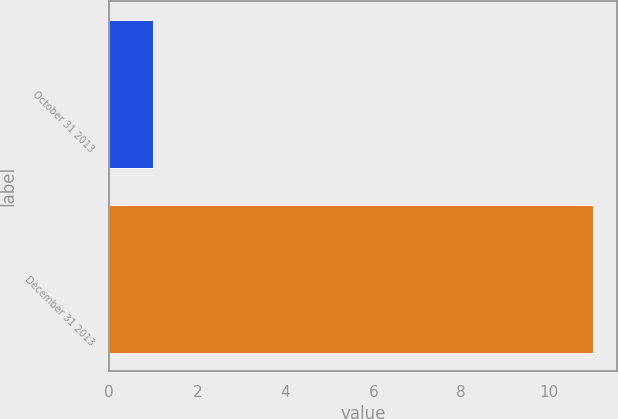Convert chart to OTSL. <chart><loc_0><loc_0><loc_500><loc_500><bar_chart><fcel>October 31 2013<fcel>December 31 2013<nl><fcel>1<fcel>11<nl></chart> 